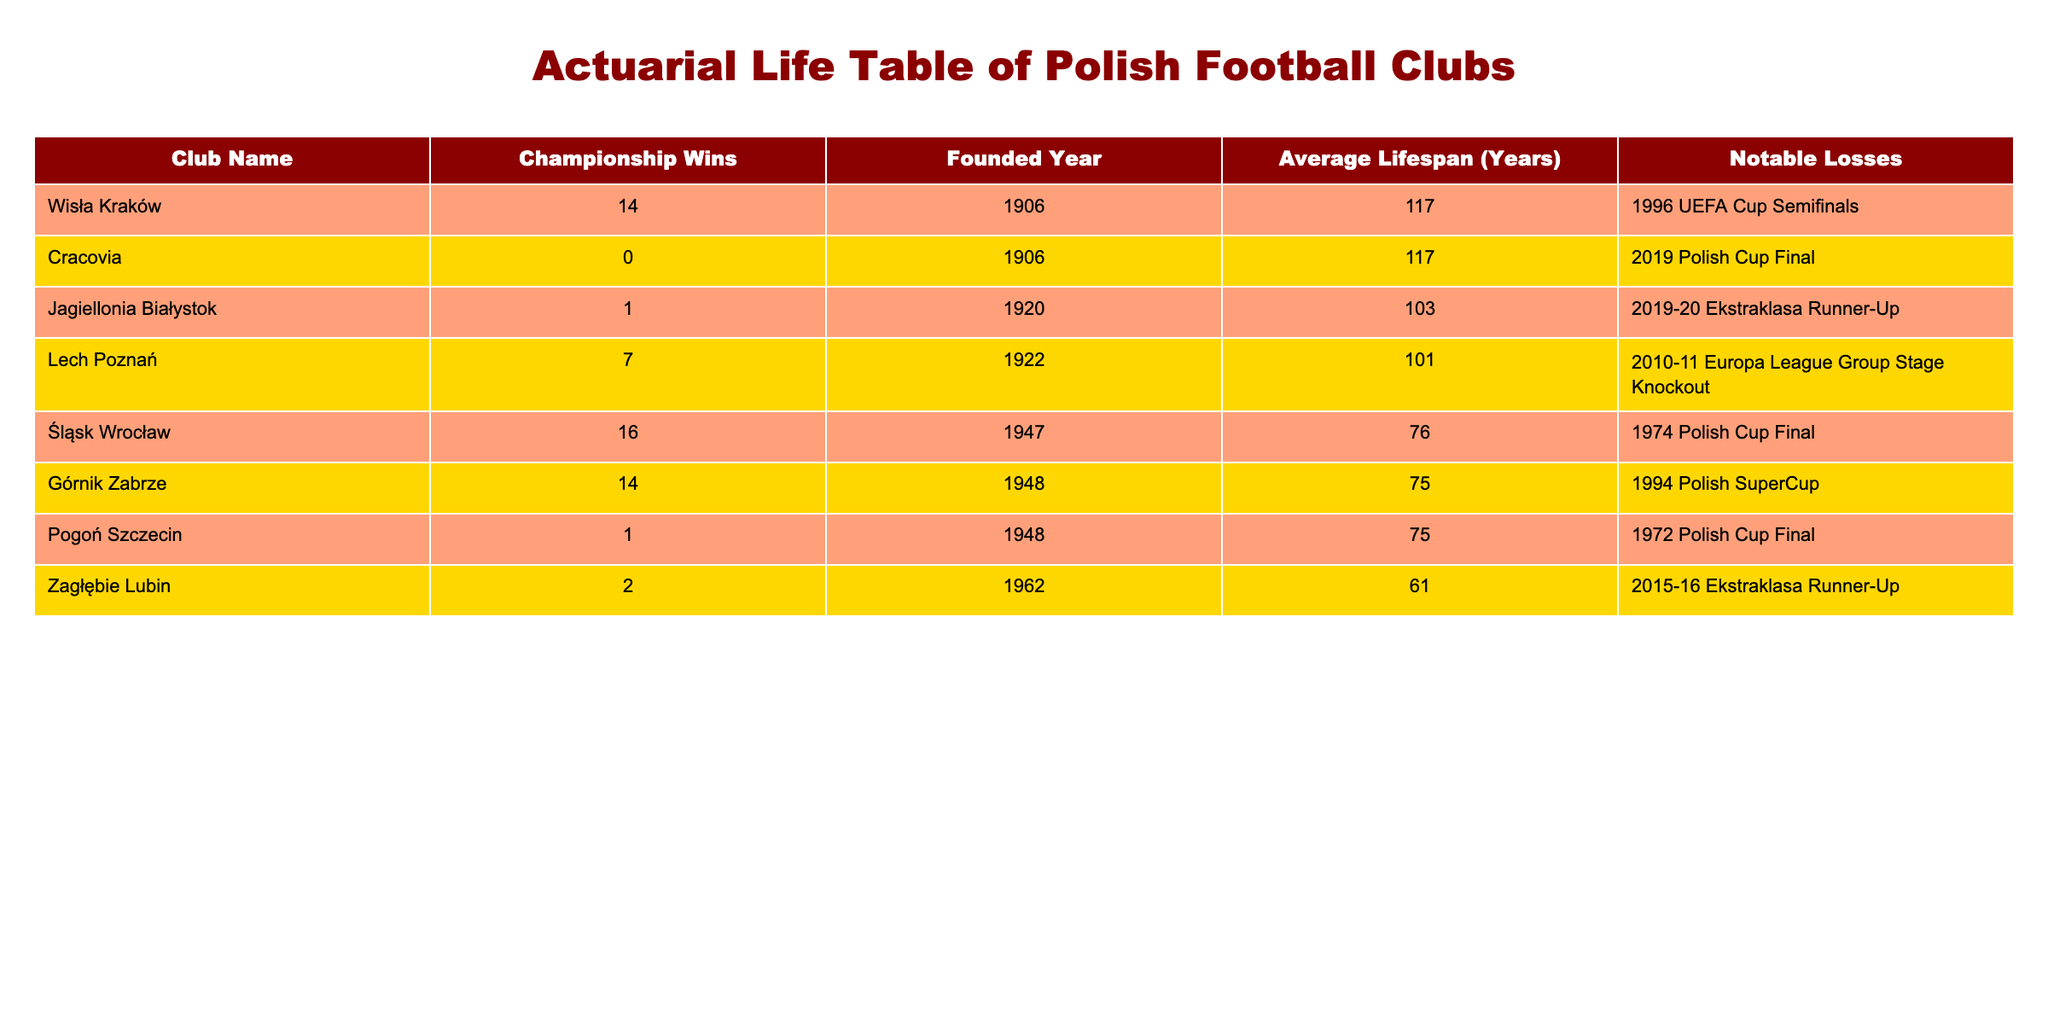What's the club with the highest average lifespan? The table shows that Cracovia and Wisła Kraków both have the highest average lifespan at 117 years.
Answer: Cracovia and Wisła Kraków Which club has the fewest championship wins? Zagłębie Lubin has the fewest championship wins with only 2 titles.
Answer: Zagłębie Lubin What is the average lifespan of clubs founded after 1940? The relevant clubs are Górnik Zabrze (75 years), Śląsk Wrocław (76 years), Zagłębie Lubin (61 years), and Pogoń Szczecin (75 years). The average is (75 + 76 + 61 + 75) / 4 = 71.75 years.
Answer: 71.75 Are there any clubs with no championship wins? Yes, Cracovia is the only club listed with zero championship wins.
Answer: Yes What is the total number of championship wins by clubs founded in the 1900s? The clubs founded in the 1900s are Wisła Kraków (14 wins) and Cracovia (0 wins). The total championship wins are 14 + 0 = 14.
Answer: 14 Which team has an average lifespan greater than 100 years and won at least 1 championship? Wisła Kraków (117 years, 14 wins) and Jagiellonia Białystok (103 years, 1 win) both meet the criteria.
Answer: Wisła Kraków and Jagiellonia Białystok What notable loss did Górnik Zabrze have? The table lists Górnik Zabrze's notable loss as the 1994 Polish SuperCup.
Answer: 1994 Polish SuperCup Which teams have an average lifespan less than the league average (75 years)? The teams with an average lifespan less than 75 years are Zagłębie Lubin (61 years) and Śląsk Wrocław (76 years), indicating that Zagłębie Lubin is the only one under the average threshold.
Answer: Zagłębie Lubin 